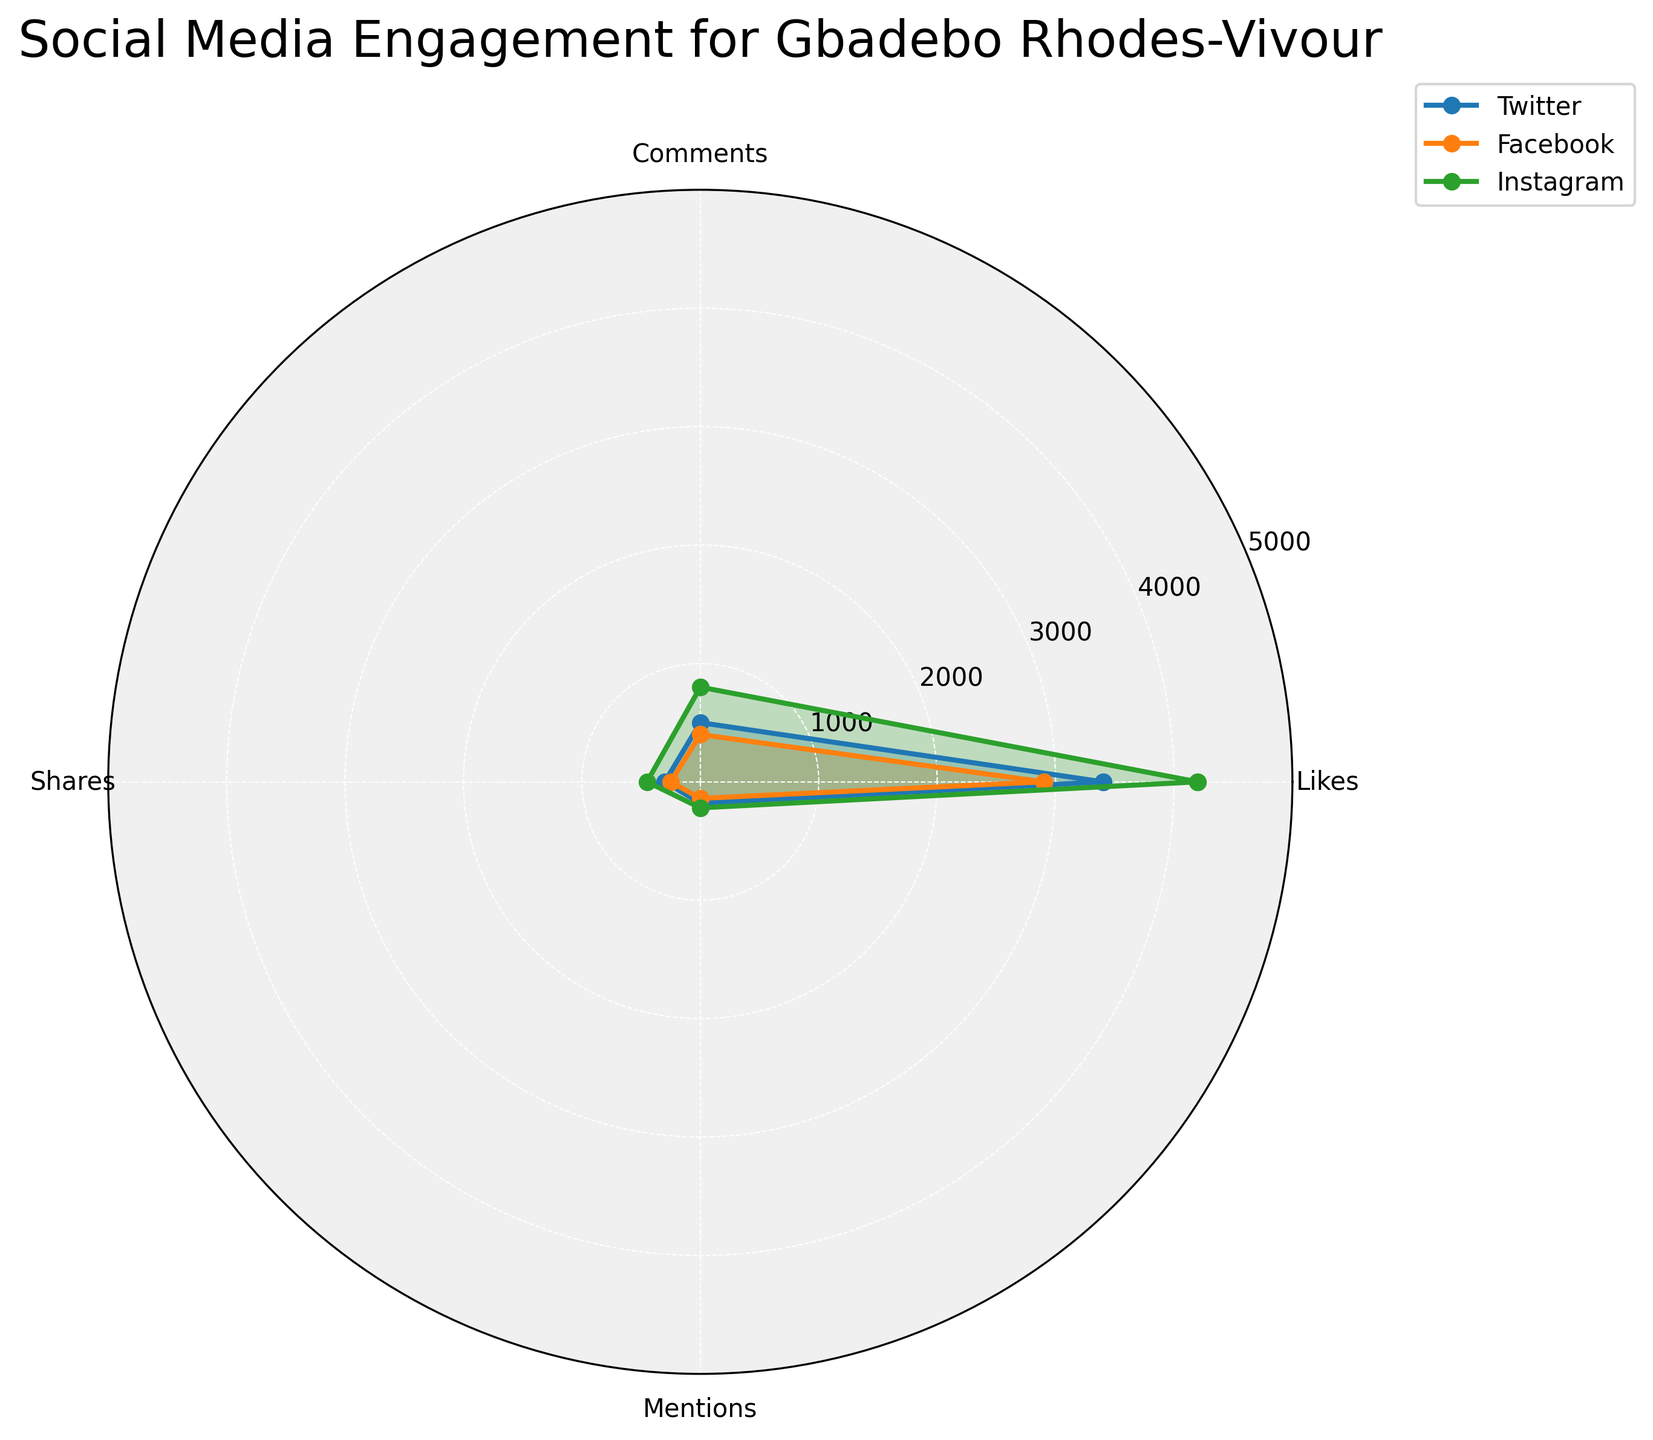What are the four engagement metrics shown in the radar chart? The radar chart displays four distinct engagement metrics, which are labeled along the axes of the chart.
Answer: Likes, Comments, Shares, Mentions Which platform shows the highest engagement in Likes? Look at the engagement values for Likes for Twitter, Facebook, and Instagram. Instagram has the highest value.
Answer: Instagram How does Facebook's Mention performance compare to Twitter's Mention performance? By comparing the values on the Mentions axis for both Facebook and Twitter, one can see that Twitter has a higher value than Facebook.
Answer: Twitter is higher What is the total engagement for Shares on Instagram? By summing up the values for Shares on Instagram across all angles (posts), i.e., 4100 + 800 + 420 + 210.
Answer: 5530 Which platform has the least engagement in Comments? Examine the Comments values for Twitter, Facebook, and Instagram. Facebook has the lowest value.
Answer: Facebook Which platform shows more even distribution across all engagement metrics? Compare all the platforms based on the evenness of their plotted values along the different engagement metrics. Twitter seems to have the most balanced values across Likes, Comments, Shares, and Mentions.
Answer: Twitter On which platform does Gbadebo Rhodes-Vivour have the lowest Likes count? Check the radar chart for the lowest value in Likes among Twitter, Facebook, and Instagram. Facebook has the lowest count.
Answer: Facebook How much higher is Instagram's Comments value compared to Twitter's Comments value? Subtract the Comments value of Twitter from that of Instagram (1000 - 700).
Answer: 300 If the engagement values for Mentions on Twitter and Facebook are combined, what is the total? Adding the Mentions values for Twitter (600) and Facebook (450) results in 600 + 450.
Answer: 1050 